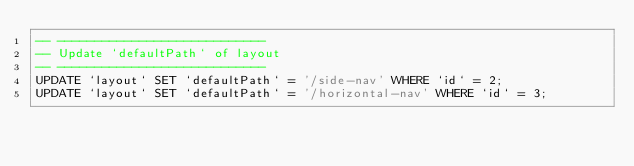<code> <loc_0><loc_0><loc_500><loc_500><_SQL_>-- ----------------------------
-- Update `defaultPath` of layout
-- ----------------------------
UPDATE `layout` SET `defaultPath` = '/side-nav' WHERE `id` = 2;
UPDATE `layout` SET `defaultPath` = '/horizontal-nav' WHERE `id` = 3;
</code> 